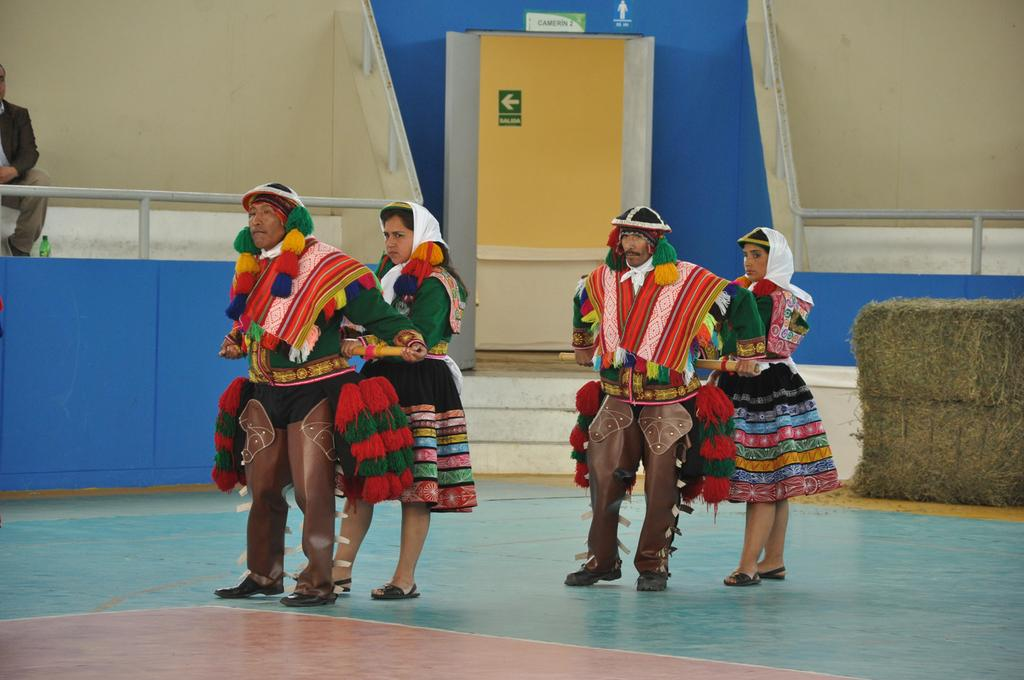How many people are present in the image? There are four people in the image. What are the people wearing? The people are wearing different costumes. Where are the people standing? The people are standing on the floor. What color is the floor? The floor is blue in color. What can be seen in the background of the image? There is railing visible in the background, and there is an exit. What type of tree can be seen in the image? There is no tree present in the image. What book is the person reading in the image? There is no person reading a book in the image. 